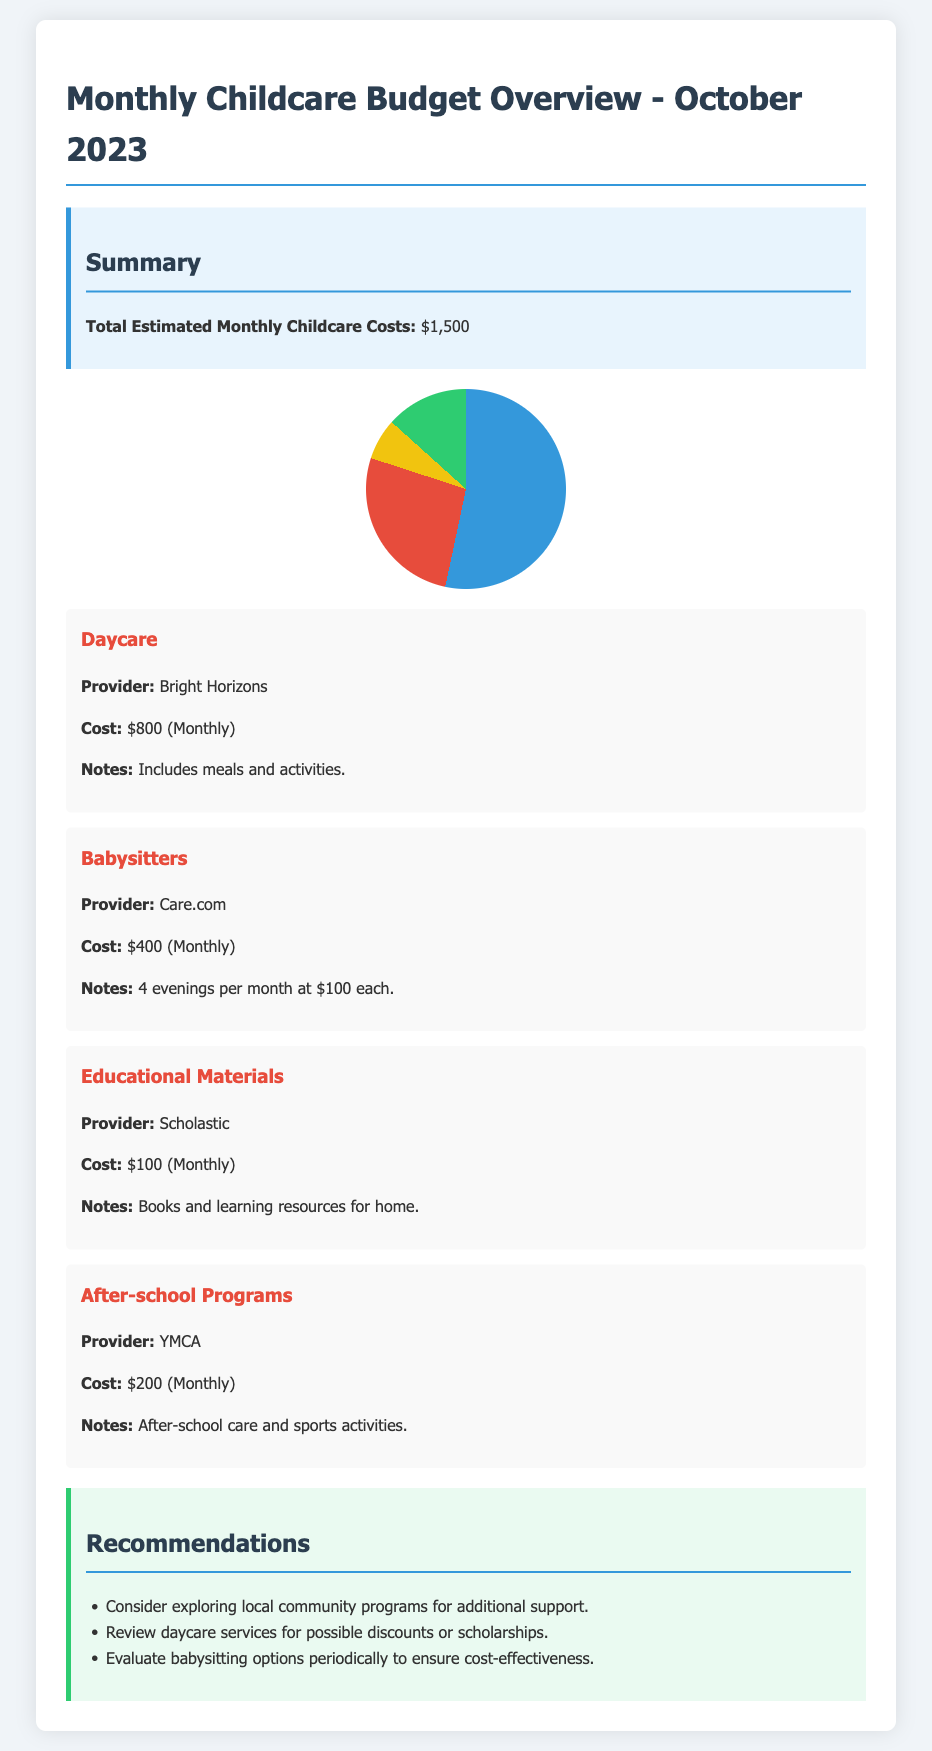What is the total estimated monthly childcare costs? The total estimated monthly childcare costs is explicitly stated in the summary section of the document.
Answer: $1,500 What is the cost for daycare? The cost for daycare is listed under the Daycare category, where Bright Horizons is the provider.
Answer: $800 Who is the provider for babysitters? The provider for babysitters is mentioned in the Babysitters category, specifically stating the service used.
Answer: Care.com What is the cost of educational materials? The cost for educational materials is provided in the Educational Materials category, summarizing the monthly expense.
Answer: $100 How much is allocated for after-school programs? The allocated amount for after-school programs is detailed in the After-school Programs category of the document.
Answer: $200 What additional recommendations are made regarding childcare expenses? Recommendations provided in the Recommendations section consider cost-saving measures, which need evaluation for effectiveness.
Answer: Local community programs How often are babysitters utilized per month? The frequency of babysitter usage is indicated in the Babysitters category, describing the number of evenings they are used.
Answer: 4 evenings What services are included in the daycare cost? Services included in the daycare cost cover meals and activities as detailed in the specific category.
Answer: Meals and activities What type of document is presented here? The document is categorized as a financial report, specifically addressing monthly childcare budget overview.
Answer: Financial report 